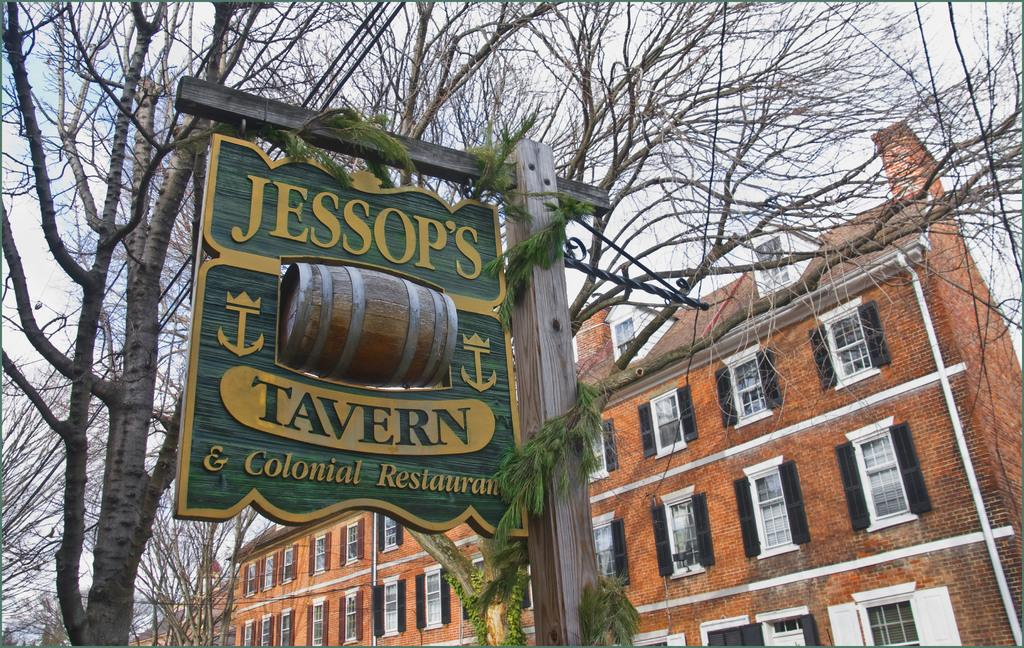What is located at the front of the image? There is a pole in the front of the image. What is written or displayed on the pole? There is a board with text on the pole. What type of natural elements can be seen in the image? There are trees in the center of the image. What type of man-made structures are visible in the background? There are buildings in the background of the image. Can you describe the woman's outfit in the image? There is no woman present in the image. Is there a fight happening in the image? There is no fight depicted in the image. 